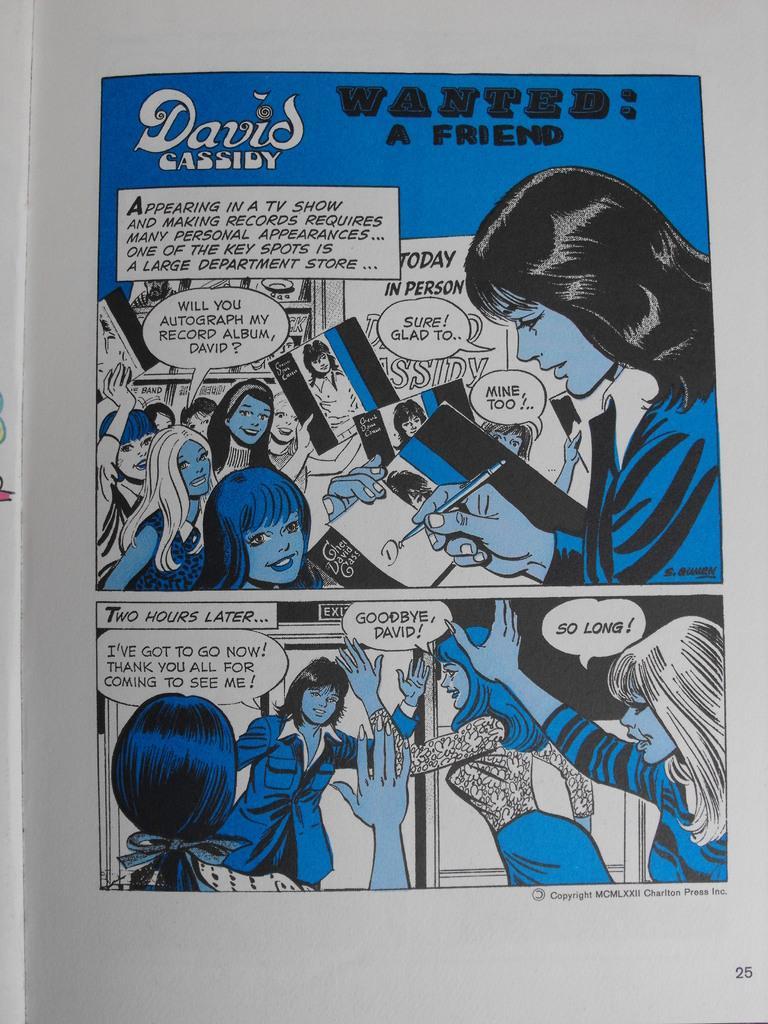Can you describe this image briefly? This is a paper and here we can see images of some people and there is some text. 